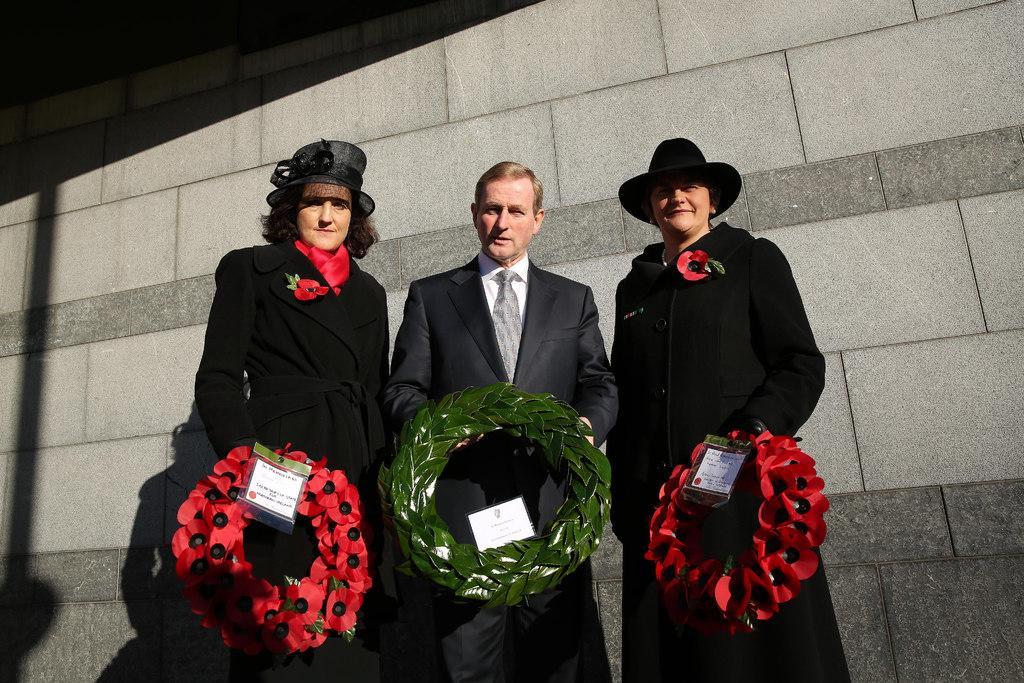Describe this image in one or two sentences. In this image I can see three persons wearing, black, white and red colored dresses are standing and holding garlands in their hands. In the background I can see the wall which is made up of bricks which is grey and ash in color. 